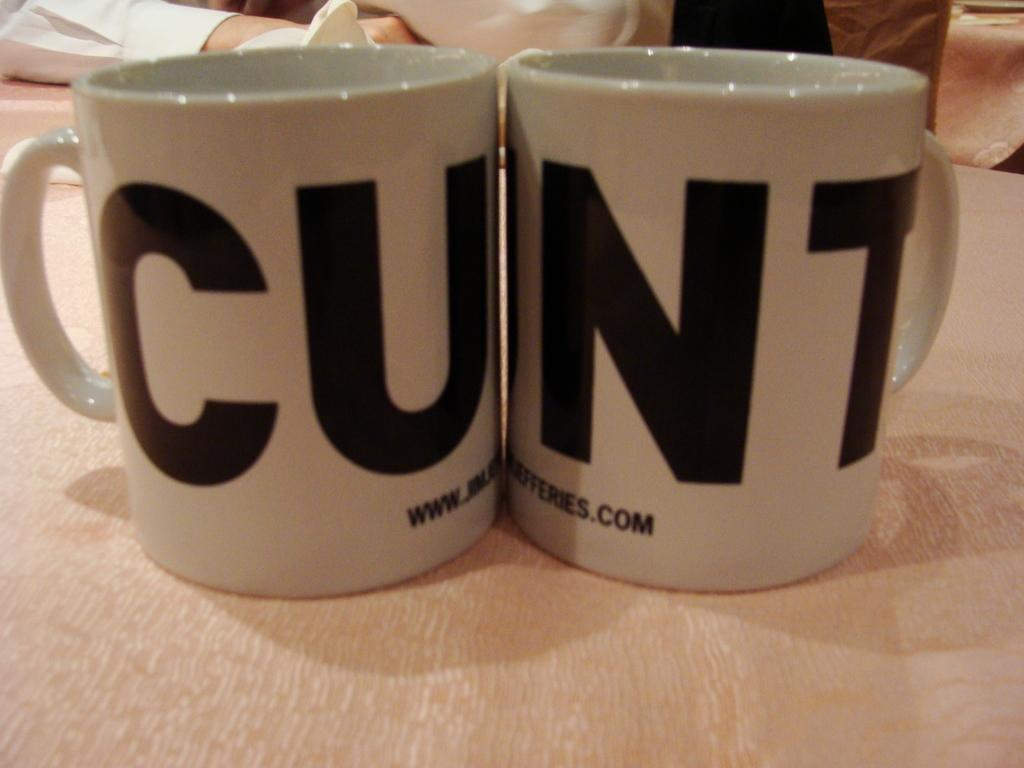<image>
Write a terse but informative summary of the picture. Two coffee mugs next to each other that spell out the word cunt. 